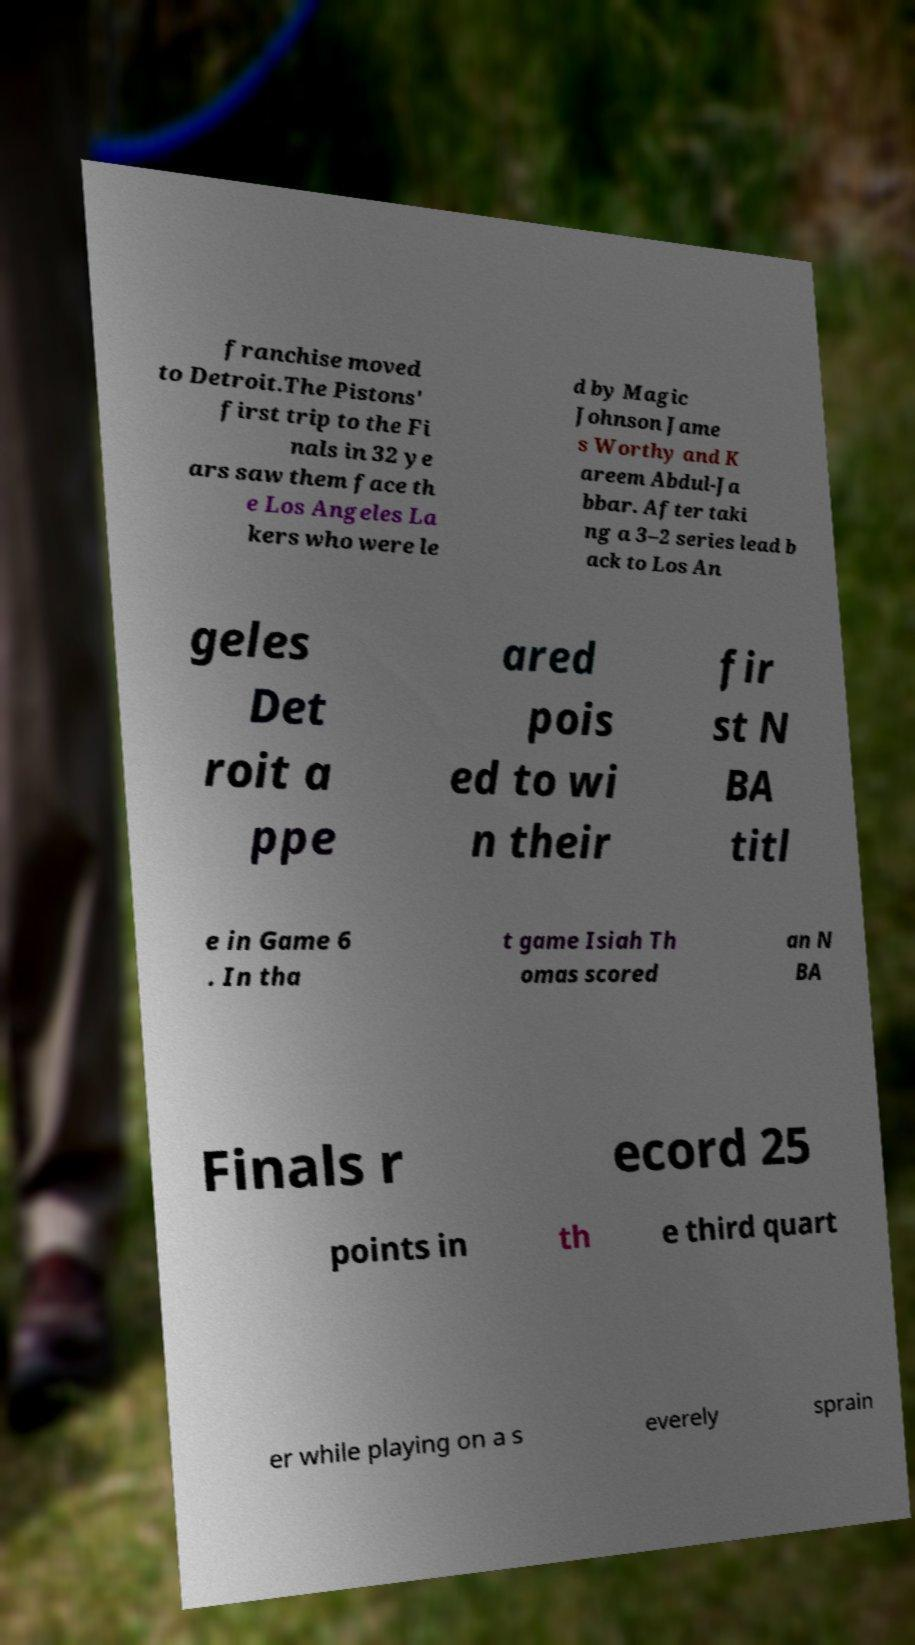Please read and relay the text visible in this image. What does it say? franchise moved to Detroit.The Pistons' first trip to the Fi nals in 32 ye ars saw them face th e Los Angeles La kers who were le d by Magic Johnson Jame s Worthy and K areem Abdul-Ja bbar. After taki ng a 3–2 series lead b ack to Los An geles Det roit a ppe ared pois ed to wi n their fir st N BA titl e in Game 6 . In tha t game Isiah Th omas scored an N BA Finals r ecord 25 points in th e third quart er while playing on a s everely sprain 